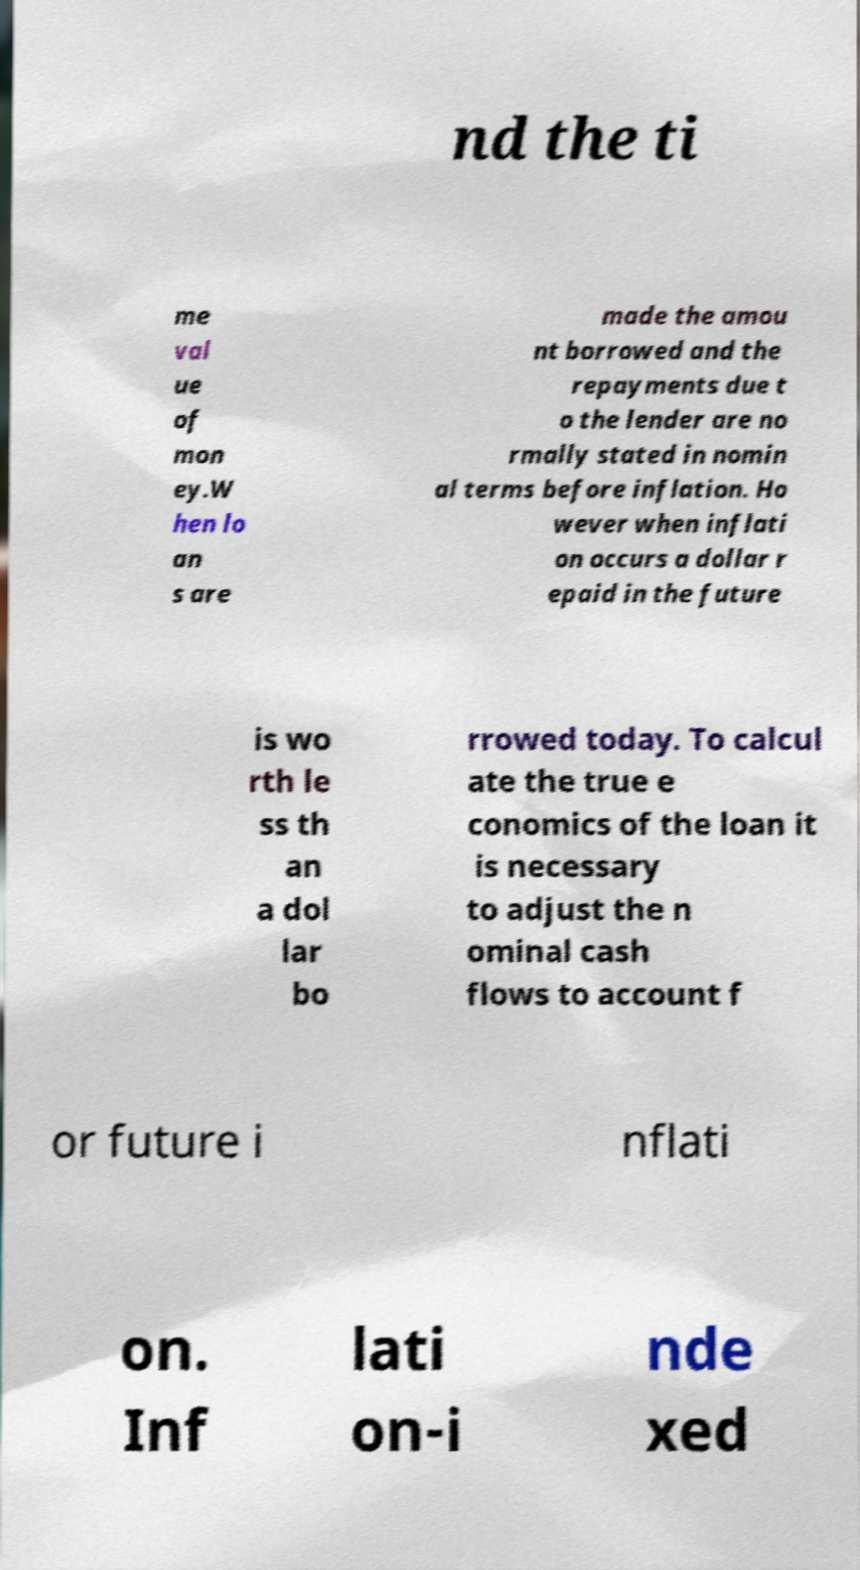Please identify and transcribe the text found in this image. nd the ti me val ue of mon ey.W hen lo an s are made the amou nt borrowed and the repayments due t o the lender are no rmally stated in nomin al terms before inflation. Ho wever when inflati on occurs a dollar r epaid in the future is wo rth le ss th an a dol lar bo rrowed today. To calcul ate the true e conomics of the loan it is necessary to adjust the n ominal cash flows to account f or future i nflati on. Inf lati on-i nde xed 